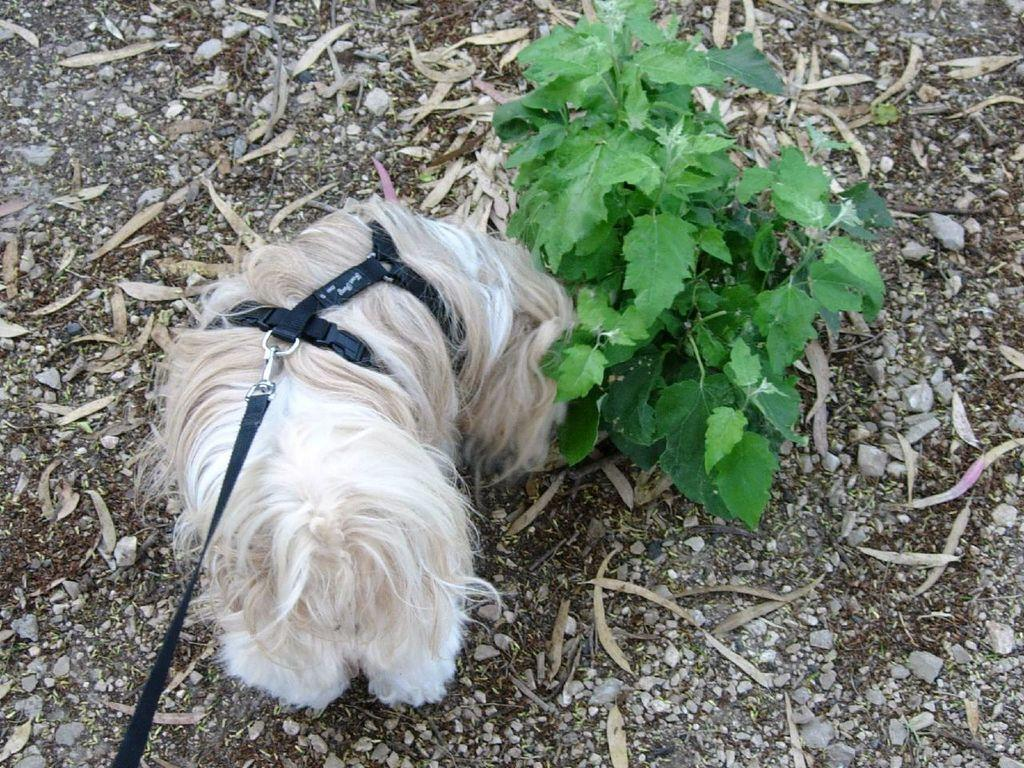What type of animal is present in the image? There is a dog in the image. What is the dog wearing? The dog is wearing a dog belt. What other object can be seen in the image? There is a plant in the image. What is on the ground in the image? There are dried leaves and small rocks on the ground. What type of behavior does the cook exhibit in the image? There is no cook present in the image, so it is not possible to answer a question about their behavior. 